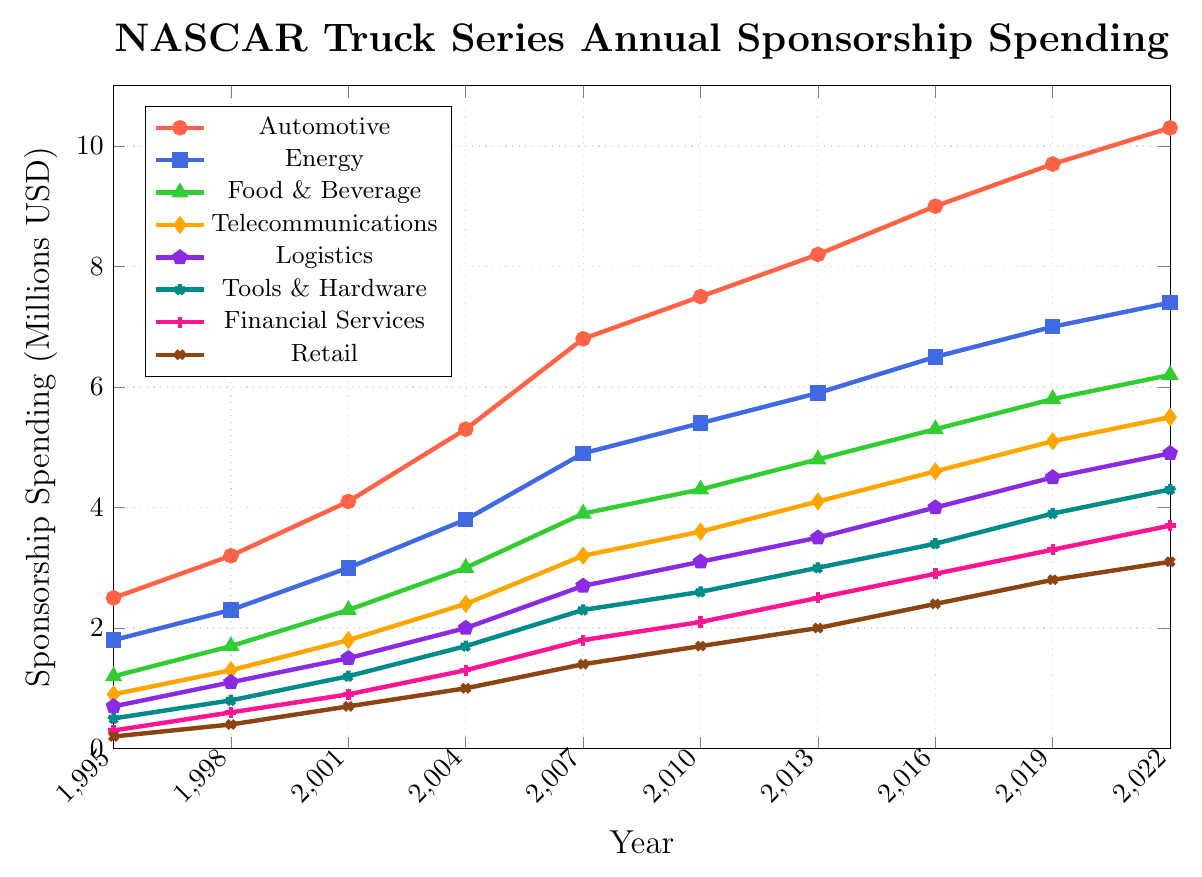What's the industry with the highest sponsorship spending in 2022? Examine the plot and identify the highest point for the year 2022. The Automotive sector spent the most, with spending reaching the highest value on the y-axis.
Answer: Automotive How much did spending for the Retail sector increase from 1995 to 2022? Look at the Retail sector spending in 1995 and 2022, and calculate the difference: $3.1 million (2022) - $0.2 million (1995) = $2.9 million.
Answer: $2.9 million Which two sectors showed the highest growth in sponsorship spending between 1995 and 2022? Compare the initial and final points for each industry. Automotive increased from $2.5 million to $10.3 million, and Energy increased from $1.8 million to $7.4 million. The difference is $7.8 million and $5.6 million, respectively, the highest among all sectors.
Answer: Automotive and Energy What is the average annual sponsorship spending of the Food & Beverage sector over the given years? Sum the values from the Food & Beverage sector for each year and divide by the number of years. ($1.2 + $1.7 + $2.3 + $3.0 + $3.9 + $4.3 + $4.8 + $5.3 + $5.8 + $6.2) / 10 = 3.85.
Answer: $3.85 million Which sector had the lowest sponsorship spending in 2001? Check the values for each sector in 2001 and identify the smallest value. The Retail sector spent $0.7 million, the lowest among all sectors listed for that year.
Answer: Retail Which year did the Energy sector's spending first exceed $4 million? Identify the year when Energy sector spending surpasses $4 million by examining the plot. In 2007, spending reached $4.9 million, surpassing $4 million for the first time.
Answer: 2007 What is the total sponsorship spending for the Logistics sector from 1995 to 2022? Sum the values for the Logistics sector for each year. $0.7 + $1.1 + $1.5 + $2.0 + $2.7 + $3.1 + $3.5 + $4.0 + $4.5 + $4.9 = $28 million.
Answer: $28 million What is the difference in sponsorship spending between the Automotive and Telecommunications sectors in 2022? Find the values for both sectors in 2022 and calculate the difference. $10.3 million (Automotive) - $5.5 million (Telecommunications) = $4.8 million.
Answer: $4.8 million Which sector showed the most consistent annual increase in spending over the years? By examining the slopes of the lines, the Automotive sector shows a consistent and steady increase each year, indicating consistent growth.
Answer: Automotive What is the combined sponsorship spending of Tools & Hardware and Financial Services sectors in 2019? Add the spending values for both sectors in 2019. $3.9 million (Tools & Hardware) + $3.3 million (Financial Services) = $7.2 million.
Answer: $7.2 million 